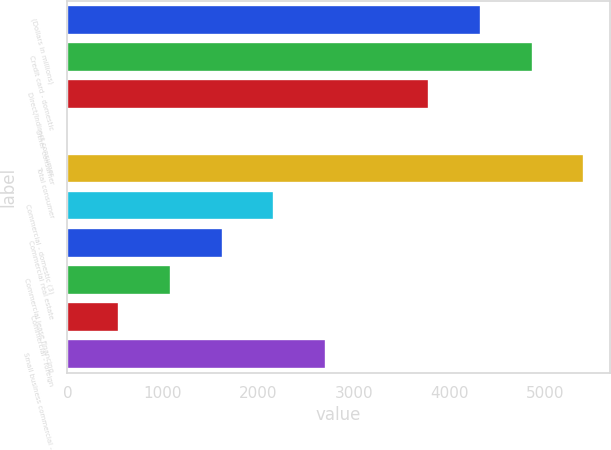<chart> <loc_0><loc_0><loc_500><loc_500><bar_chart><fcel>(Dollars in millions)<fcel>Credit card - domestic<fcel>Direct/Indirect consumer<fcel>Other consumer<fcel>Total consumer<fcel>Commercial - domestic (3)<fcel>Commercial real estate<fcel>Commercial lease financing<fcel>Commercial - foreign<fcel>Small business commercial -<nl><fcel>4332<fcel>4873<fcel>3791<fcel>4<fcel>5414<fcel>2168<fcel>1627<fcel>1086<fcel>545<fcel>2709<nl></chart> 